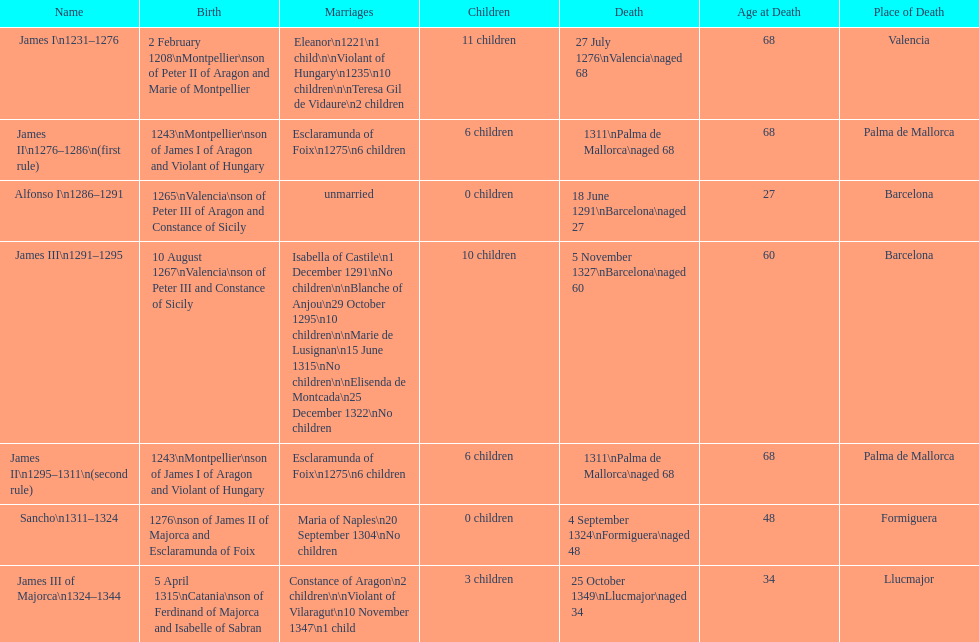Was james iii or sancho born in the year 1276? Sancho. 